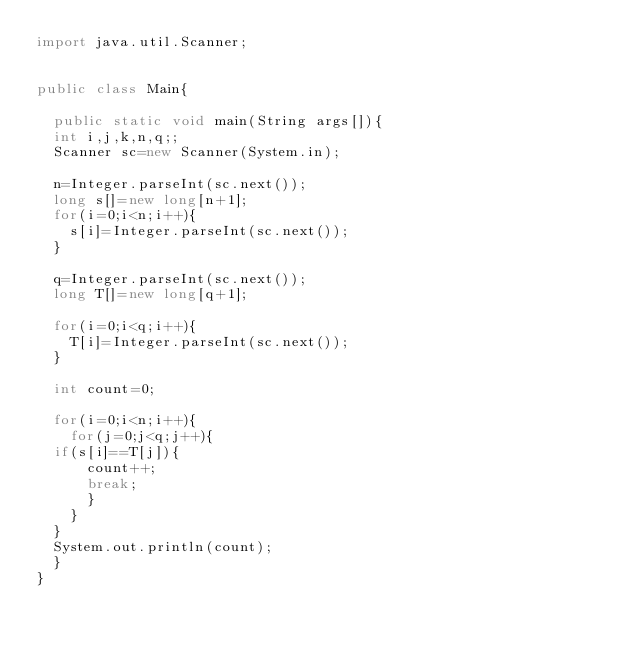Convert code to text. <code><loc_0><loc_0><loc_500><loc_500><_Java_>import java.util.Scanner;


public class Main{

	public static void main(String args[]){
	int i,j,k,n,q;;
	Scanner sc=new Scanner(System.in);
	
	n=Integer.parseInt(sc.next());
	long s[]=new long[n+1];
	for(i=0;i<n;i++){
		s[i]=Integer.parseInt(sc.next());
	}
	
	q=Integer.parseInt(sc.next());
	long T[]=new long[q+1];
	
	for(i=0;i<q;i++){
		T[i]=Integer.parseInt(sc.next());
	}
	
	int count=0;
	
	for(i=0;i<n;i++){
		for(j=0;j<q;j++){
	if(s[i]==T[j]){
			count++;
			break;
			}
		}	
	}
	System.out.println(count);
	}
}</code> 